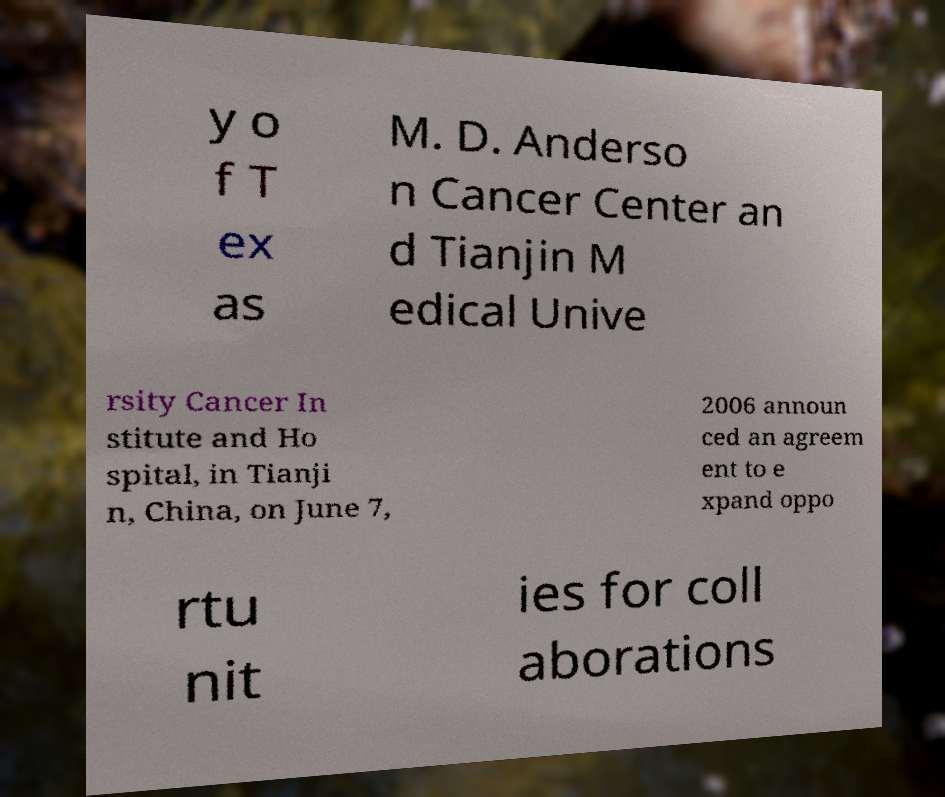Please identify and transcribe the text found in this image. y o f T ex as M. D. Anderso n Cancer Center an d Tianjin M edical Unive rsity Cancer In stitute and Ho spital, in Tianji n, China, on June 7, 2006 announ ced an agreem ent to e xpand oppo rtu nit ies for coll aborations 